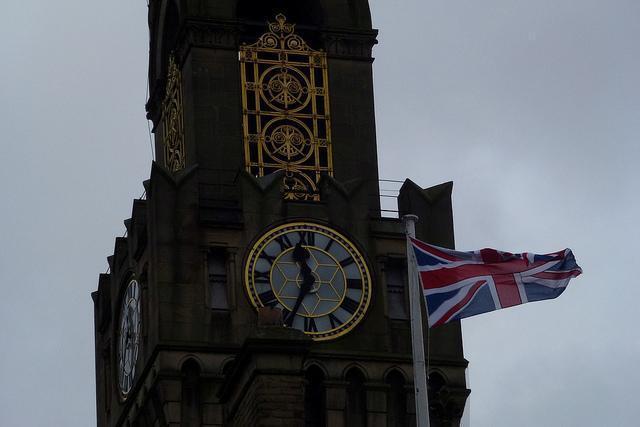How many clocks can be seen?
Give a very brief answer. 2. How many sheep are grazing?
Give a very brief answer. 0. 